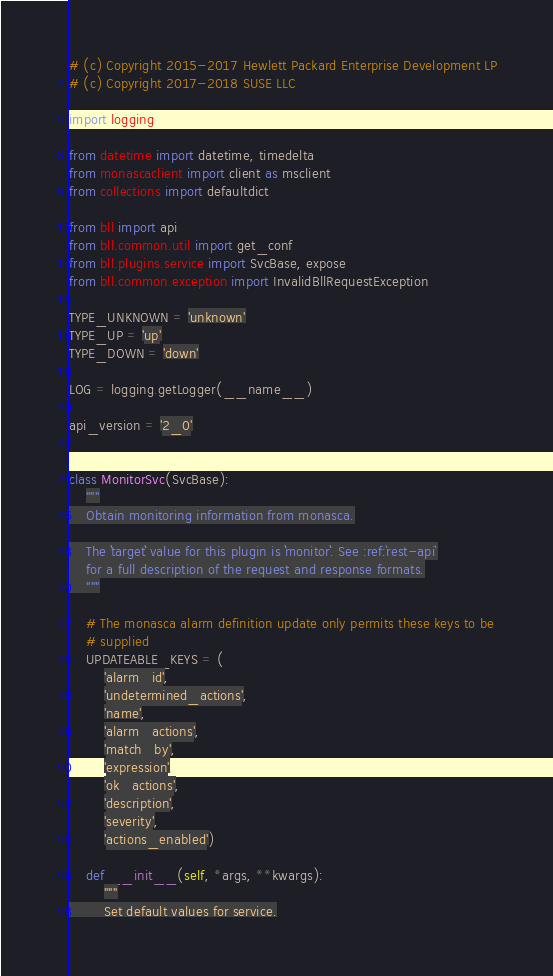Convert code to text. <code><loc_0><loc_0><loc_500><loc_500><_Python_># (c) Copyright 2015-2017 Hewlett Packard Enterprise Development LP
# (c) Copyright 2017-2018 SUSE LLC

import logging

from datetime import datetime, timedelta
from monascaclient import client as msclient
from collections import defaultdict

from bll import api
from bll.common.util import get_conf
from bll.plugins.service import SvcBase, expose
from bll.common.exception import InvalidBllRequestException

TYPE_UNKNOWN = 'unknown'
TYPE_UP = 'up'
TYPE_DOWN = 'down'

LOG = logging.getLogger(__name__)

api_version = '2_0'


class MonitorSvc(SvcBase):
    """
    Obtain monitoring information from monasca.

    The ``target`` value for this plugin is ``monitor``. See :ref:`rest-api`
    for a full description of the request and response formats.
    """

    # The monasca alarm definition update only permits these keys to be
    # supplied
    UPDATEABLE_KEYS = (
        'alarm_id',
        'undetermined_actions',
        'name',
        'alarm_actions',
        'match_by',
        'expression',
        'ok_actions',
        'description',
        'severity',
        'actions_enabled')

    def __init__(self, *args, **kwargs):
        """
        Set default values for service.</code> 